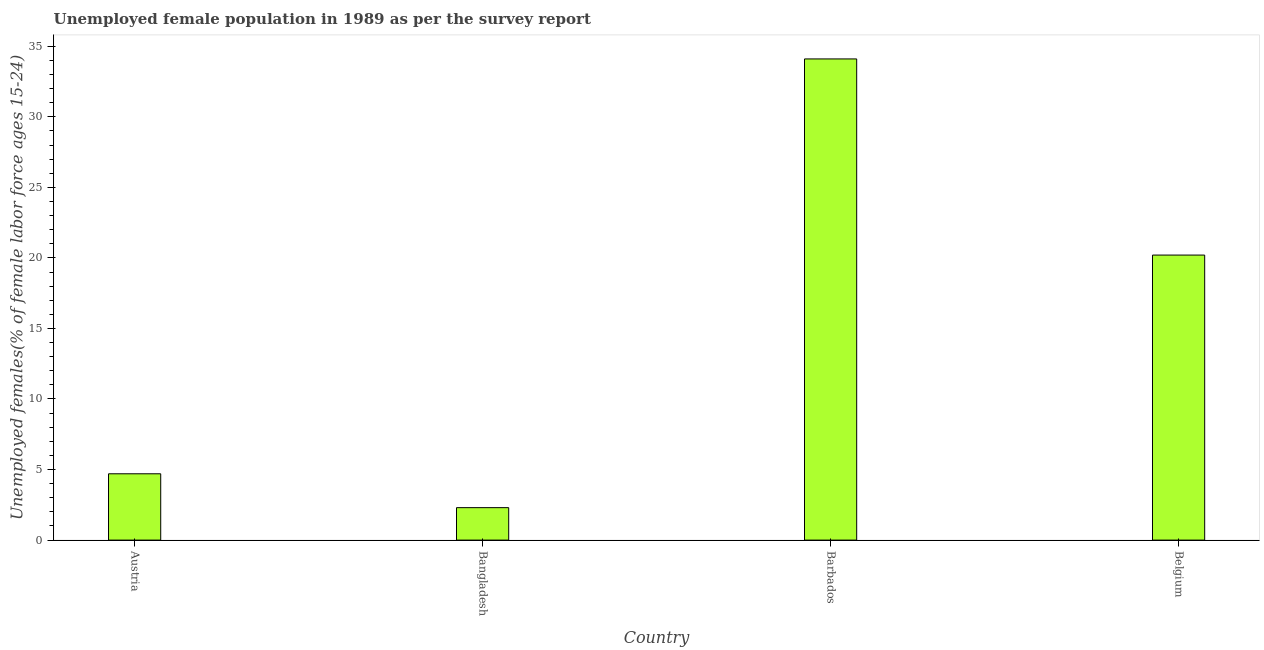What is the title of the graph?
Offer a very short reply. Unemployed female population in 1989 as per the survey report. What is the label or title of the X-axis?
Your answer should be very brief. Country. What is the label or title of the Y-axis?
Make the answer very short. Unemployed females(% of female labor force ages 15-24). What is the unemployed female youth in Bangladesh?
Give a very brief answer. 2.3. Across all countries, what is the maximum unemployed female youth?
Your response must be concise. 34.1. Across all countries, what is the minimum unemployed female youth?
Ensure brevity in your answer.  2.3. In which country was the unemployed female youth maximum?
Your response must be concise. Barbados. What is the sum of the unemployed female youth?
Your response must be concise. 61.3. What is the average unemployed female youth per country?
Make the answer very short. 15.32. What is the median unemployed female youth?
Give a very brief answer. 12.45. What is the ratio of the unemployed female youth in Austria to that in Bangladesh?
Keep it short and to the point. 2.04. What is the difference between the highest and the lowest unemployed female youth?
Offer a terse response. 31.8. In how many countries, is the unemployed female youth greater than the average unemployed female youth taken over all countries?
Ensure brevity in your answer.  2. How many bars are there?
Your response must be concise. 4. How many countries are there in the graph?
Keep it short and to the point. 4. What is the difference between two consecutive major ticks on the Y-axis?
Provide a succinct answer. 5. Are the values on the major ticks of Y-axis written in scientific E-notation?
Give a very brief answer. No. What is the Unemployed females(% of female labor force ages 15-24) in Austria?
Make the answer very short. 4.7. What is the Unemployed females(% of female labor force ages 15-24) in Bangladesh?
Your response must be concise. 2.3. What is the Unemployed females(% of female labor force ages 15-24) of Barbados?
Give a very brief answer. 34.1. What is the Unemployed females(% of female labor force ages 15-24) of Belgium?
Ensure brevity in your answer.  20.2. What is the difference between the Unemployed females(% of female labor force ages 15-24) in Austria and Barbados?
Provide a short and direct response. -29.4. What is the difference between the Unemployed females(% of female labor force ages 15-24) in Austria and Belgium?
Your response must be concise. -15.5. What is the difference between the Unemployed females(% of female labor force ages 15-24) in Bangladesh and Barbados?
Your response must be concise. -31.8. What is the difference between the Unemployed females(% of female labor force ages 15-24) in Bangladesh and Belgium?
Offer a very short reply. -17.9. What is the difference between the Unemployed females(% of female labor force ages 15-24) in Barbados and Belgium?
Your response must be concise. 13.9. What is the ratio of the Unemployed females(% of female labor force ages 15-24) in Austria to that in Bangladesh?
Your answer should be compact. 2.04. What is the ratio of the Unemployed females(% of female labor force ages 15-24) in Austria to that in Barbados?
Your answer should be very brief. 0.14. What is the ratio of the Unemployed females(% of female labor force ages 15-24) in Austria to that in Belgium?
Your answer should be compact. 0.23. What is the ratio of the Unemployed females(% of female labor force ages 15-24) in Bangladesh to that in Barbados?
Your answer should be compact. 0.07. What is the ratio of the Unemployed females(% of female labor force ages 15-24) in Bangladesh to that in Belgium?
Provide a succinct answer. 0.11. What is the ratio of the Unemployed females(% of female labor force ages 15-24) in Barbados to that in Belgium?
Make the answer very short. 1.69. 